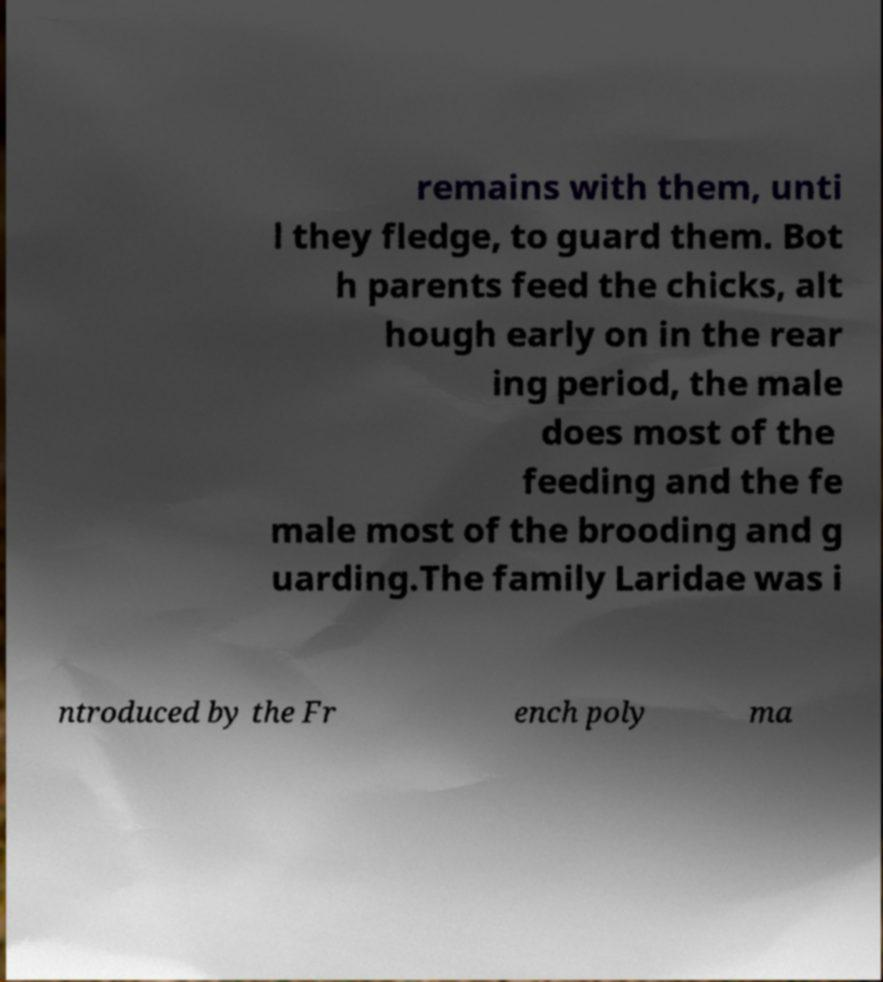Please identify and transcribe the text found in this image. remains with them, unti l they fledge, to guard them. Bot h parents feed the chicks, alt hough early on in the rear ing period, the male does most of the feeding and the fe male most of the brooding and g uarding.The family Laridae was i ntroduced by the Fr ench poly ma 